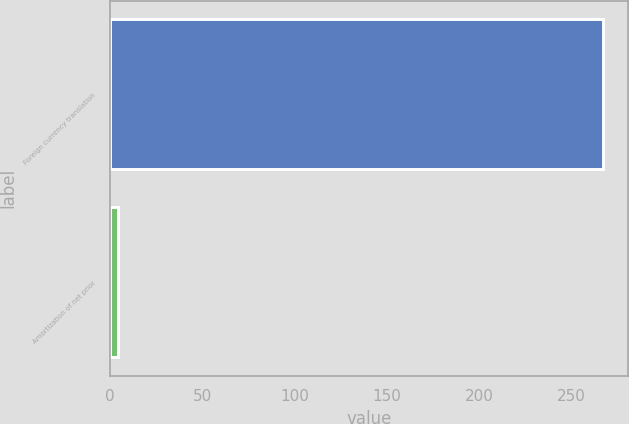Convert chart to OTSL. <chart><loc_0><loc_0><loc_500><loc_500><bar_chart><fcel>Foreign currency translation<fcel>Amortization of net prior<nl><fcel>266.9<fcel>4.3<nl></chart> 